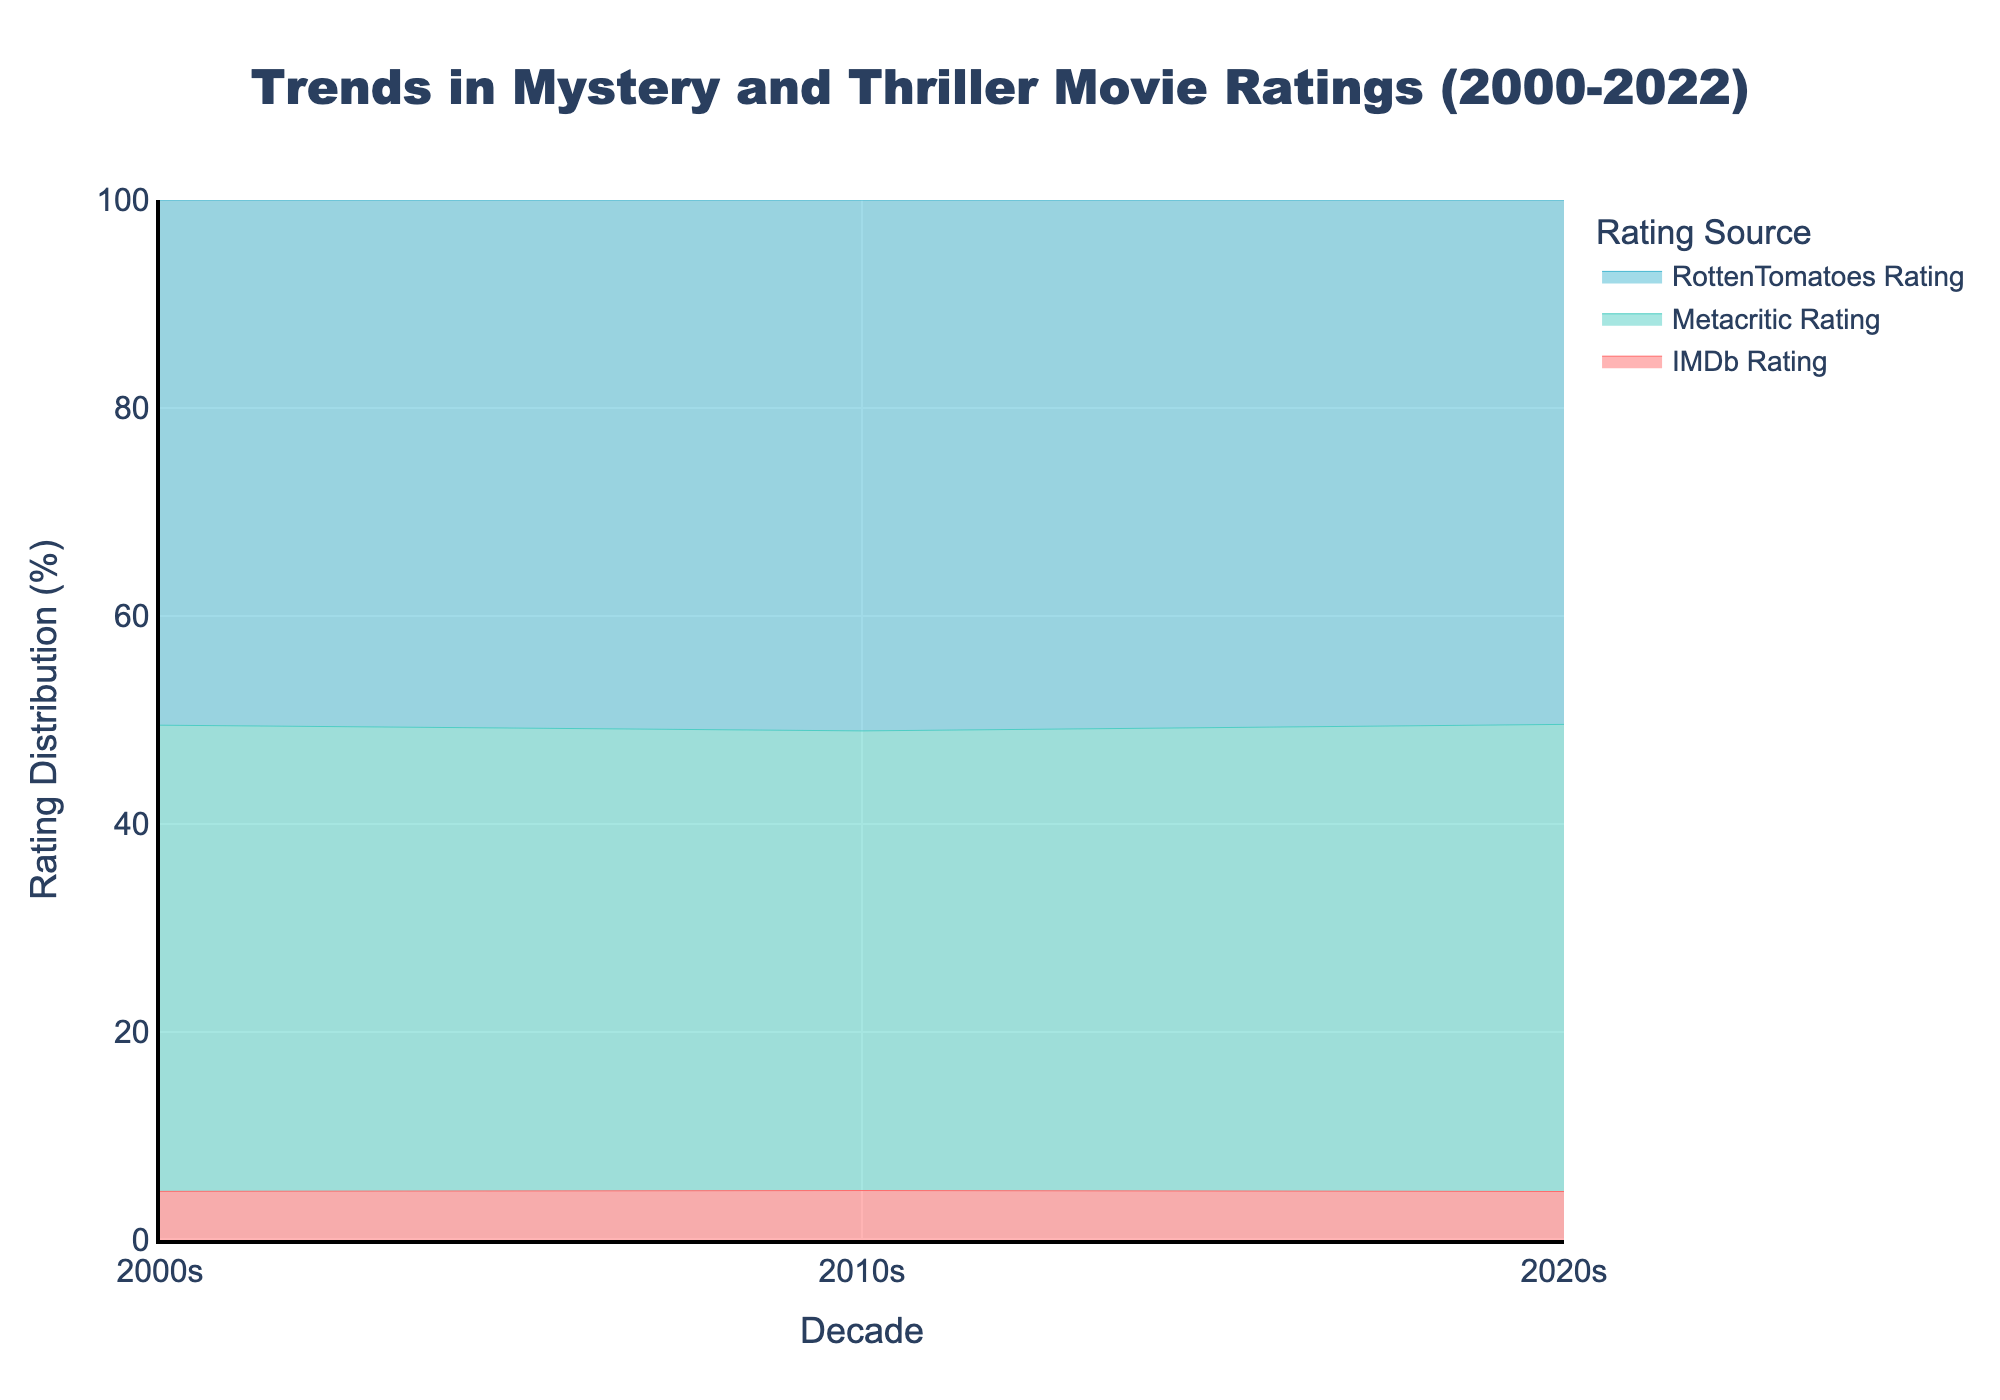What's the title of the figure? The title is located at the top of the figure and is prominently displayed.
Answer: Trends in Mystery and Thriller Movie Ratings (2000-2022) What time period does the x-axis cover? The x-axis labels indicate the time periods covered, which are the decades.
Answer: 2000-2022 What color represents the IMDb Rating in the graph? The IMDb Rating trace is represented by a unique color.
Answer: Red How does the percentage of Rotten Tomatoes ratings change from 2000s to 2020s? To answer this, observe the height of the Rotten Tomatoes section of the stack area for each decade and notice the change.
Answer: Decreases Which rating source has the highest percentage in the 2010s? By comparing the height of each colored segment in the stack for the 2010s, you can identify which one is the largest.
Answer: IMDb Rating What's the average IMDb Rating percentage across these three decades? Calculate the IMDb Rating percentage for each decade and then find the average. Explanation: summing the percentages for three decades and dividing by 3.
Answer: (approx.) 38.5% Compare the trend of Metacritic Ratings between 2000s and 2010s. Determine if the Metacritic percentage increased, decreased, or stayed the same by comparing their segment height in these decades.
Answer: Increased Between 2000s and 2020s, which decade shows the highest Rotten Tomatoes Rating percentage? View the Rotten Tomatoes section for the two decades and compare their heights to determine which is higher.
Answer: 2000s What’s the general trend of IMDb Ratings from 2000s to 2020s? Observe the overall change in the height of the IMDb section from left to right across the decades to identify if it rises, falls, or stabilizes.
Answer: Decreases What is the combined percentage of Metacritic and Rotten Tomatoes ratings in the 2020s? Add the heights of the Metacritic and Rotten Tomatoes segments in the 2020s to find the combined percentage.
Answer: (approx.) 37.5% 